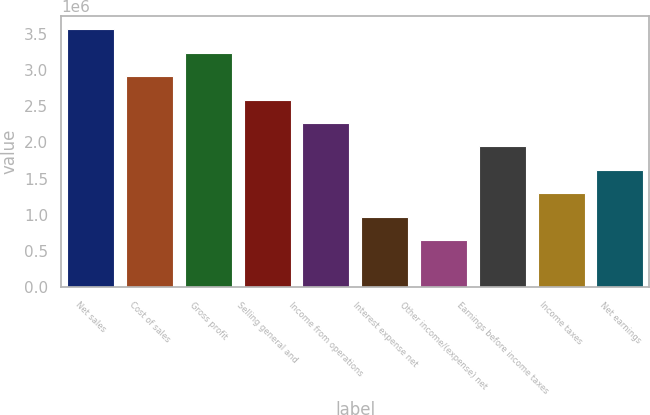<chart> <loc_0><loc_0><loc_500><loc_500><bar_chart><fcel>Net sales<fcel>Cost of sales<fcel>Gross profit<fcel>Selling general and<fcel>Income from operations<fcel>Interest expense net<fcel>Other income/(expense) net<fcel>Earnings before income taxes<fcel>Income taxes<fcel>Net earnings<nl><fcel>3.56194e+06<fcel>2.91432e+06<fcel>3.23813e+06<fcel>2.5905e+06<fcel>2.26669e+06<fcel>971442<fcel>647630<fcel>1.94288e+06<fcel>1.29525e+06<fcel>1.61907e+06<nl></chart> 